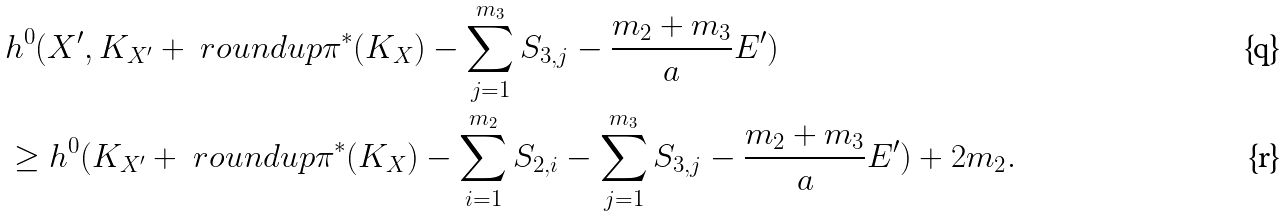Convert formula to latex. <formula><loc_0><loc_0><loc_500><loc_500>& h ^ { 0 } ( X ^ { \prime } , K _ { X ^ { \prime } } + \ r o u n d u p { \pi ^ { * } ( K _ { X } ) - \sum _ { j = 1 } ^ { m _ { 3 } } S _ { 3 , j } - \frac { m _ { 2 } + m _ { 3 } } { a } E ^ { \prime } } ) \\ & \geq h ^ { 0 } ( K _ { X ^ { \prime } } + \ r o u n d u p { \pi ^ { * } ( K _ { X } ) - \sum _ { i = 1 } ^ { m _ { 2 } } S _ { 2 , i } - \sum _ { j = 1 } ^ { m _ { 3 } } S _ { 3 , j } - \frac { m _ { 2 } + m _ { 3 } } { a } E ^ { \prime } } ) + 2 m _ { 2 } .</formula> 